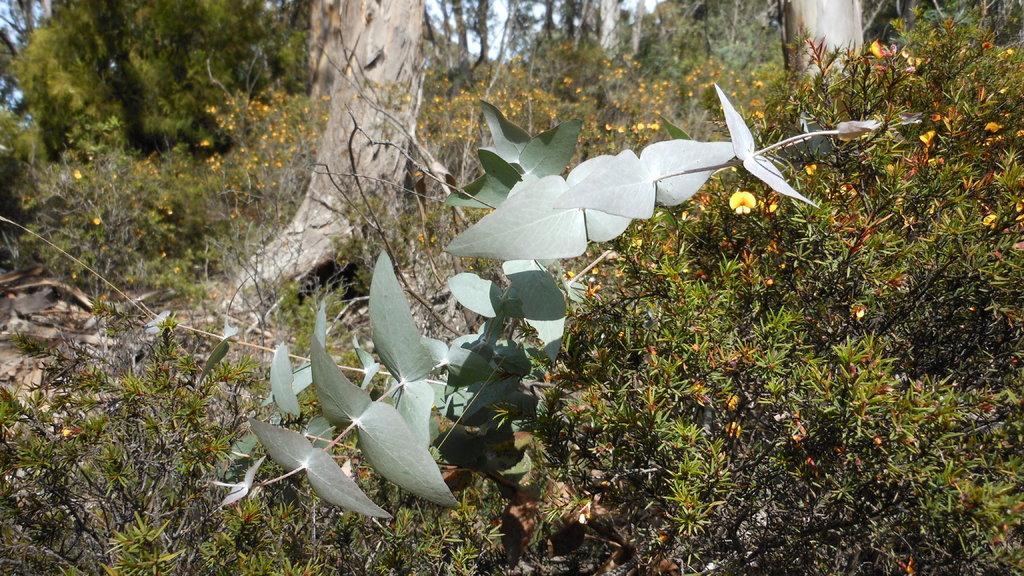Please provide a concise description of this image. This is a picture taken in a field. In the foreground of the picture there are plants, leaves. In the center of the picture there are trees, plants and flowers. It is sunny. 